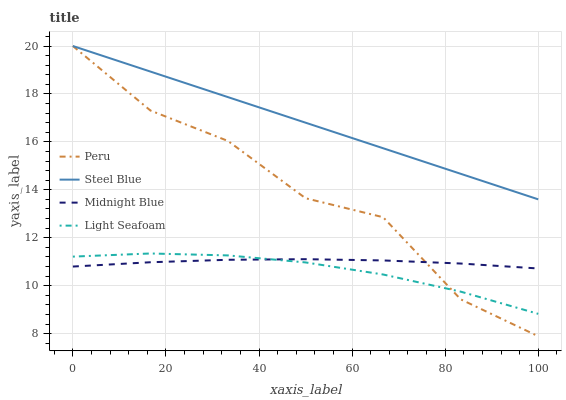Does Light Seafoam have the minimum area under the curve?
Answer yes or no. Yes. Does Steel Blue have the maximum area under the curve?
Answer yes or no. Yes. Does Peru have the minimum area under the curve?
Answer yes or no. No. Does Peru have the maximum area under the curve?
Answer yes or no. No. Is Steel Blue the smoothest?
Answer yes or no. Yes. Is Peru the roughest?
Answer yes or no. Yes. Is Peru the smoothest?
Answer yes or no. No. Is Steel Blue the roughest?
Answer yes or no. No. Does Peru have the lowest value?
Answer yes or no. Yes. Does Steel Blue have the lowest value?
Answer yes or no. No. Does Peru have the highest value?
Answer yes or no. Yes. Does Midnight Blue have the highest value?
Answer yes or no. No. Is Light Seafoam less than Steel Blue?
Answer yes or no. Yes. Is Steel Blue greater than Midnight Blue?
Answer yes or no. Yes. Does Peru intersect Light Seafoam?
Answer yes or no. Yes. Is Peru less than Light Seafoam?
Answer yes or no. No. Is Peru greater than Light Seafoam?
Answer yes or no. No. Does Light Seafoam intersect Steel Blue?
Answer yes or no. No. 